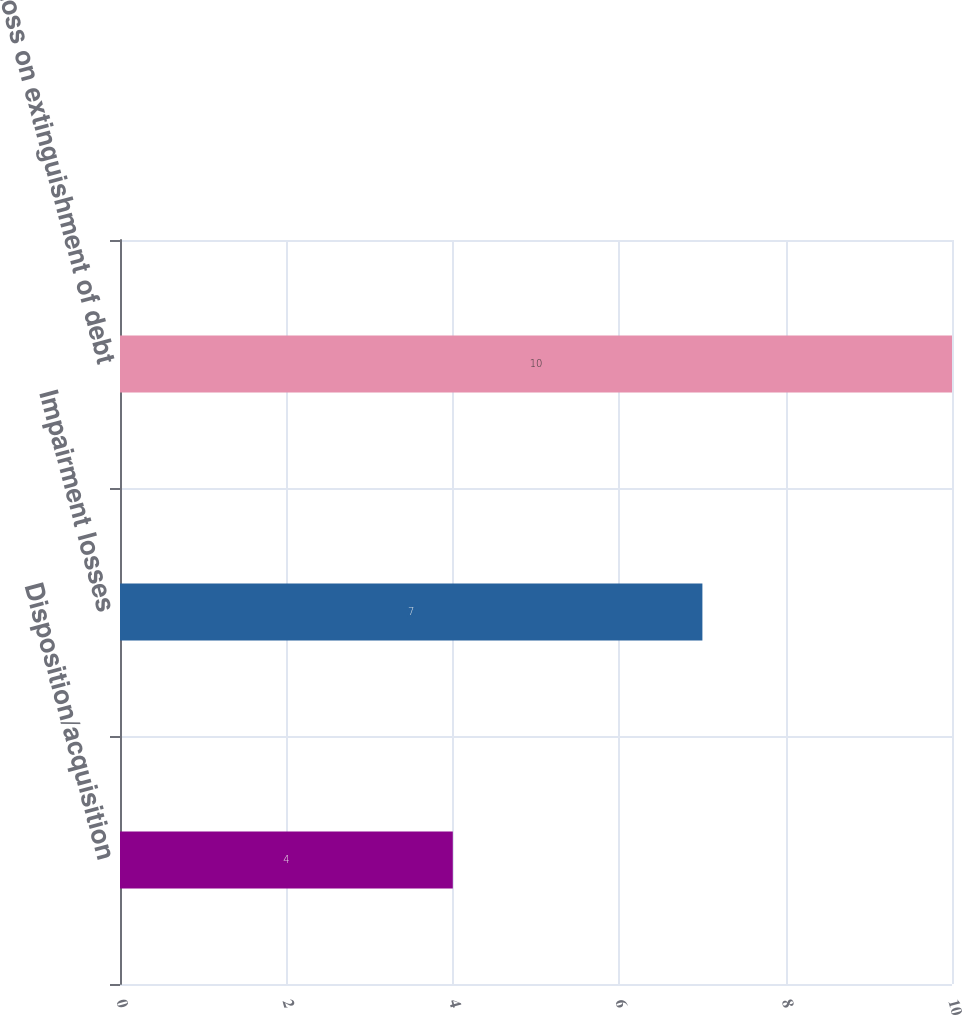Convert chart to OTSL. <chart><loc_0><loc_0><loc_500><loc_500><bar_chart><fcel>Disposition/acquisition<fcel>Impairment losses<fcel>Loss on extinguishment of debt<nl><fcel>4<fcel>7<fcel>10<nl></chart> 